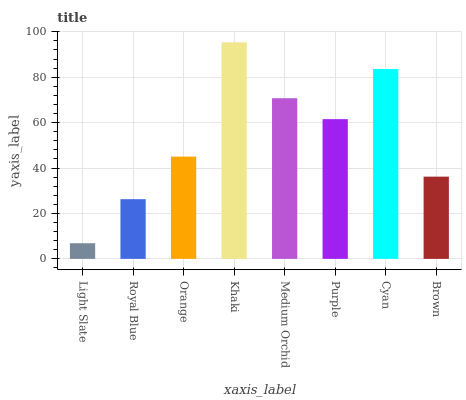Is Light Slate the minimum?
Answer yes or no. Yes. Is Khaki the maximum?
Answer yes or no. Yes. Is Royal Blue the minimum?
Answer yes or no. No. Is Royal Blue the maximum?
Answer yes or no. No. Is Royal Blue greater than Light Slate?
Answer yes or no. Yes. Is Light Slate less than Royal Blue?
Answer yes or no. Yes. Is Light Slate greater than Royal Blue?
Answer yes or no. No. Is Royal Blue less than Light Slate?
Answer yes or no. No. Is Purple the high median?
Answer yes or no. Yes. Is Orange the low median?
Answer yes or no. Yes. Is Cyan the high median?
Answer yes or no. No. Is Purple the low median?
Answer yes or no. No. 